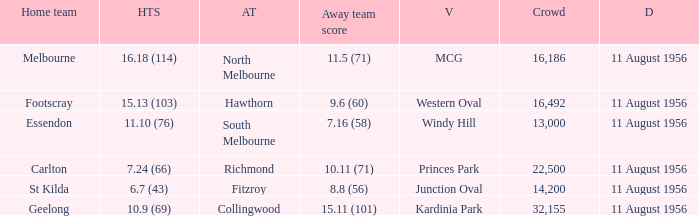What home team has a score of 16.18 (114)? Melbourne. 